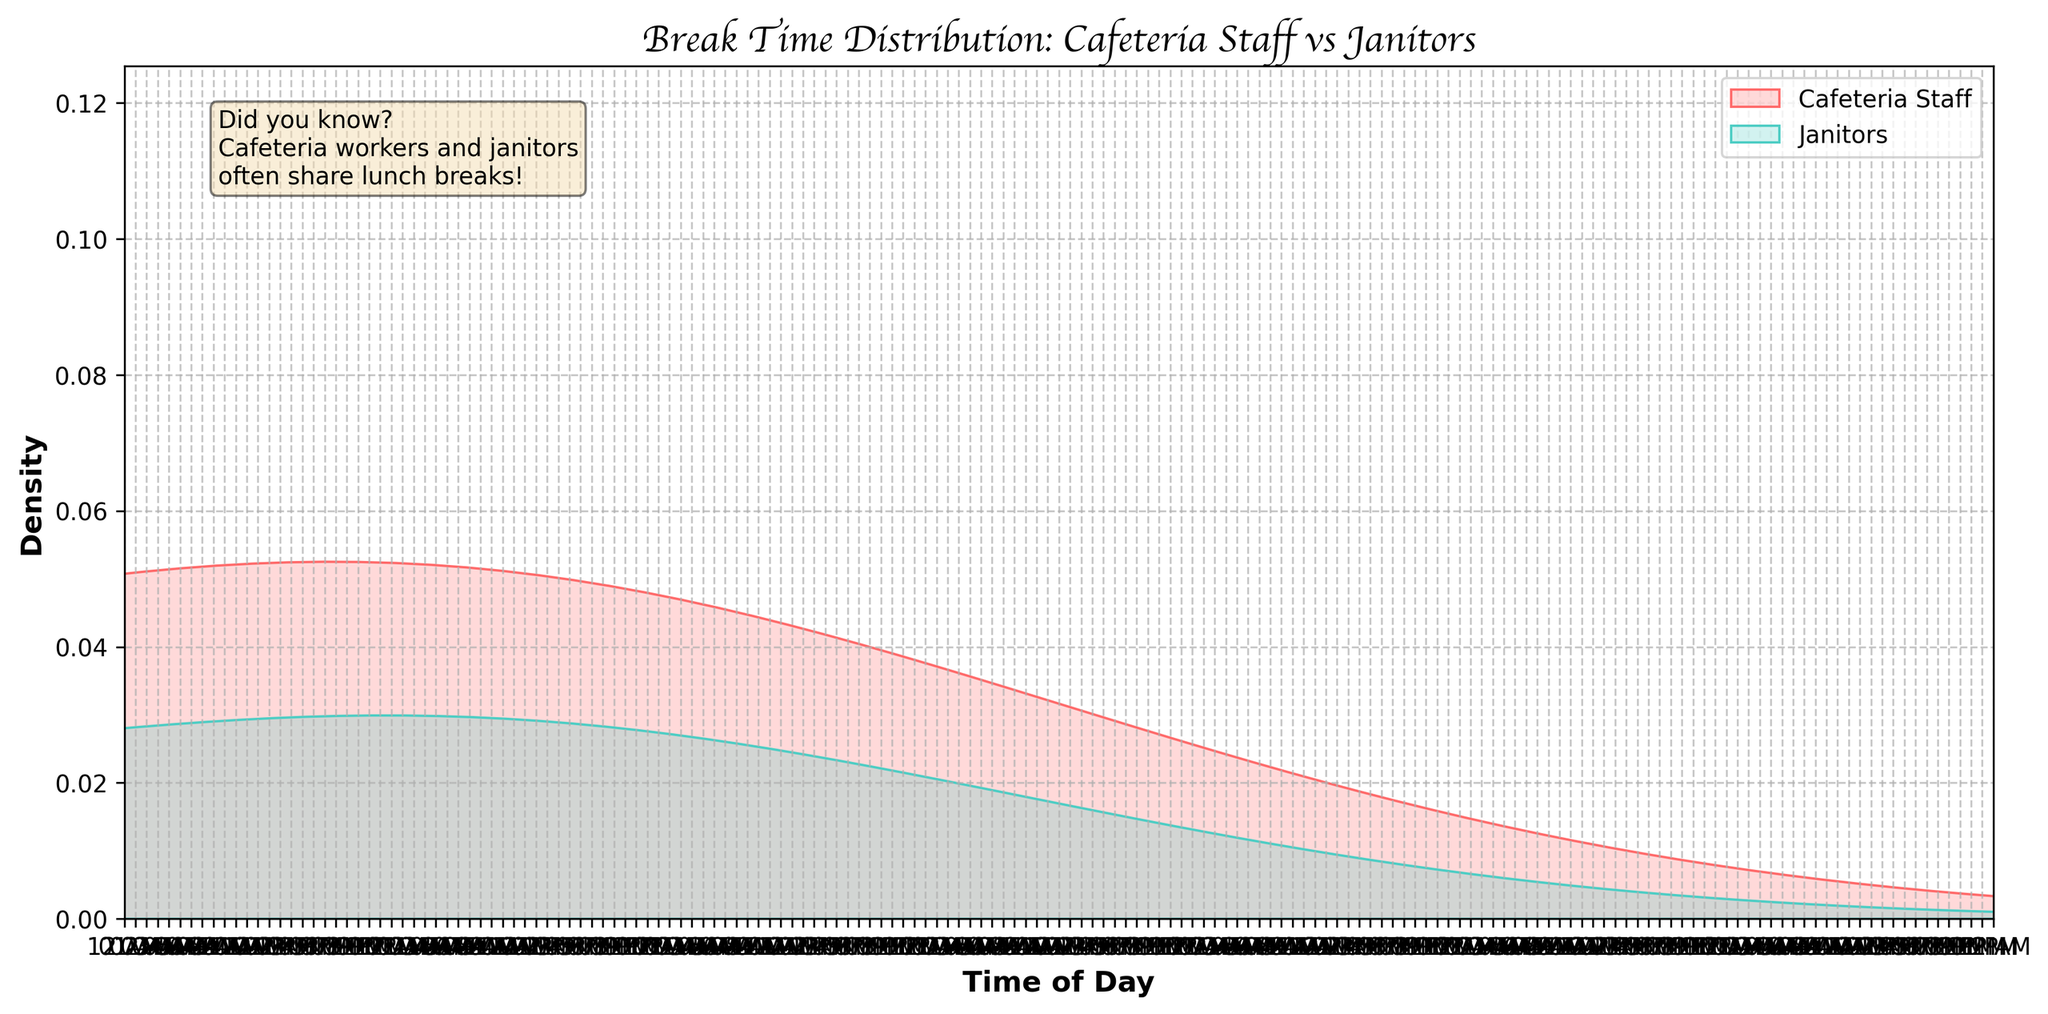what's the title of the figure? The title of the figure is usually displayed at the top of the plot. In this figure, the title is "Break Time Distribution: Cafeteria Staff vs Janitors". This title provides an overview of what the plot is about, which is the distribution of break times for cafeteria staff compared to janitors.
Answer: Break Time Distribution: Cafeteria Staff vs Janitors what are the colors used to represent cafeteria staff and janitors? The figure distinguishes between break times of cafeteria staff and janitors using different colors. Cafeteria staff breaks are represented by a shade of red, while janitor breaks are represented by a shade of turquoise.
Answer: Red and Turquoise what time frame does the x-axis cover? The x-axis shows the time of day from 10:00 AM to 5:00 PM. This can be seen by observing the time ticks displayed along the x-axis, which start at 10:00 AM and end at 5:00 PM as intervals of one hour are represented.
Answer: 10:00 AM to 5:00 PM which group has more density around 12:00 PM? By examining the density around the 12:00 PM mark on the x-axis, it is clear that the janitor group (represented in turquoise) shows a higher peak in density than the cafeteria staff (represented in red).
Answer: Janitors what is the general trend of break times for cafeteria workers compared to janitors? The density plot shows that cafeteria staff break times are spread across the morning and afternoon with a peak noise around 2:00 PM. In contrast, janitors typically take their breaks evenly from 11:00 AM to 4:00 PM.
Answer: Cafeteria staff have variable breaks throughout the day, while janitors have more evenly distributed breaks during which time range do janitors take most of their breaks? Based on the density plot for the janitors (in turquoise), the breaks are more prominent from 11:00 AM to 3:30 PM. This is observed by the higher density values within this range.
Answer: 11:00 AM to 3:30 PM who takes breaks earlier in the day, cafeteria staff or janitors? The density plot indicates that cafeteria staff start taking breaks as early as 10:15 AM, while janitors start their breaks around 11:00 AM. Hence, cafeteria staff take their breaks earlier in the day compared to janitors.
Answer: Cafeteria staff how do the break densities compare in the 3:00 PM to 4:00 PM window? During the 3:00 PM to 4:00 PM window, the density for cafeteria staff shows an upward trend, whereas the density for janitors starts to taper off. This comparison is based on the declining density of turquoise and increasing density of red in the specified time window.
Answer: Cafeteria staff have an increasing density, janitors have a decreasing density which group tends to take breaks during the later part of the day, according to the density plot's tail end? The tail end of the density plot (4:00 PM onwards) shows that cafeteria staff (red) take more breaks compared to janitors (turquoise), indicating that cafeteria staff tend to take breaks later in the day.
Answer: Cafeteria staff how does the density of break times differ between 11:00 AM and 12:00 PM for each group? Between 11:00 AM and 12:00 PM, the density for janitors increases, peaking around this period, while the density for cafeteria staff is lower and more spread out. This can be seen from the higher rise of the turquoise curve compared to the red curve in this interval.
Answer: Janitors have a higher break density than cafeteria staff in this time frame 